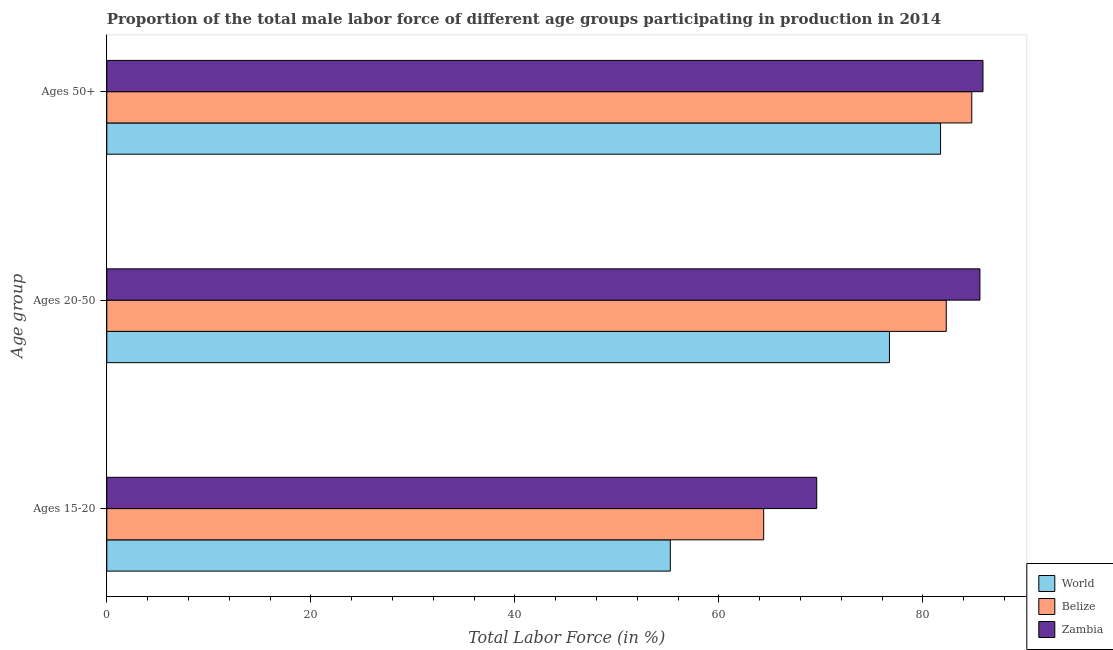How many groups of bars are there?
Keep it short and to the point. 3. Are the number of bars on each tick of the Y-axis equal?
Provide a succinct answer. Yes. How many bars are there on the 3rd tick from the top?
Your response must be concise. 3. How many bars are there on the 3rd tick from the bottom?
Your answer should be compact. 3. What is the label of the 1st group of bars from the top?
Ensure brevity in your answer.  Ages 50+. What is the percentage of male labor force within the age group 20-50 in Zambia?
Ensure brevity in your answer.  85.6. Across all countries, what is the maximum percentage of male labor force above age 50?
Provide a short and direct response. 85.9. Across all countries, what is the minimum percentage of male labor force within the age group 15-20?
Offer a terse response. 55.24. In which country was the percentage of male labor force within the age group 20-50 maximum?
Your answer should be very brief. Zambia. In which country was the percentage of male labor force within the age group 20-50 minimum?
Provide a succinct answer. World. What is the total percentage of male labor force above age 50 in the graph?
Offer a very short reply. 252.44. What is the difference between the percentage of male labor force within the age group 20-50 in Belize and that in Zambia?
Provide a short and direct response. -3.3. What is the difference between the percentage of male labor force above age 50 in World and the percentage of male labor force within the age group 15-20 in Zambia?
Your response must be concise. 12.14. What is the average percentage of male labor force within the age group 20-50 per country?
Your answer should be compact. 81.54. What is the difference between the percentage of male labor force above age 50 and percentage of male labor force within the age group 20-50 in Zambia?
Your response must be concise. 0.3. What is the ratio of the percentage of male labor force within the age group 15-20 in Belize to that in Zambia?
Ensure brevity in your answer.  0.93. Is the percentage of male labor force above age 50 in World less than that in Zambia?
Keep it short and to the point. Yes. Is the difference between the percentage of male labor force within the age group 20-50 in Zambia and Belize greater than the difference between the percentage of male labor force above age 50 in Zambia and Belize?
Keep it short and to the point. Yes. What is the difference between the highest and the second highest percentage of male labor force above age 50?
Ensure brevity in your answer.  1.1. What is the difference between the highest and the lowest percentage of male labor force within the age group 20-50?
Offer a very short reply. 8.87. In how many countries, is the percentage of male labor force above age 50 greater than the average percentage of male labor force above age 50 taken over all countries?
Provide a succinct answer. 2. Is the sum of the percentage of male labor force above age 50 in Zambia and World greater than the maximum percentage of male labor force within the age group 20-50 across all countries?
Make the answer very short. Yes. What does the 2nd bar from the top in Ages 50+ represents?
Provide a short and direct response. Belize. What does the 3rd bar from the bottom in Ages 50+ represents?
Your answer should be very brief. Zambia. Are all the bars in the graph horizontal?
Give a very brief answer. Yes. What is the difference between two consecutive major ticks on the X-axis?
Offer a very short reply. 20. Are the values on the major ticks of X-axis written in scientific E-notation?
Keep it short and to the point. No. How many legend labels are there?
Your answer should be compact. 3. What is the title of the graph?
Keep it short and to the point. Proportion of the total male labor force of different age groups participating in production in 2014. What is the label or title of the X-axis?
Keep it short and to the point. Total Labor Force (in %). What is the label or title of the Y-axis?
Offer a terse response. Age group. What is the Total Labor Force (in %) of World in Ages 15-20?
Your answer should be very brief. 55.24. What is the Total Labor Force (in %) in Belize in Ages 15-20?
Provide a short and direct response. 64.4. What is the Total Labor Force (in %) in Zambia in Ages 15-20?
Provide a short and direct response. 69.6. What is the Total Labor Force (in %) in World in Ages 20-50?
Your response must be concise. 76.73. What is the Total Labor Force (in %) of Belize in Ages 20-50?
Give a very brief answer. 82.3. What is the Total Labor Force (in %) in Zambia in Ages 20-50?
Give a very brief answer. 85.6. What is the Total Labor Force (in %) in World in Ages 50+?
Provide a succinct answer. 81.74. What is the Total Labor Force (in %) in Belize in Ages 50+?
Keep it short and to the point. 84.8. What is the Total Labor Force (in %) in Zambia in Ages 50+?
Make the answer very short. 85.9. Across all Age group, what is the maximum Total Labor Force (in %) of World?
Provide a succinct answer. 81.74. Across all Age group, what is the maximum Total Labor Force (in %) in Belize?
Your answer should be compact. 84.8. Across all Age group, what is the maximum Total Labor Force (in %) of Zambia?
Provide a short and direct response. 85.9. Across all Age group, what is the minimum Total Labor Force (in %) in World?
Your answer should be very brief. 55.24. Across all Age group, what is the minimum Total Labor Force (in %) in Belize?
Offer a very short reply. 64.4. Across all Age group, what is the minimum Total Labor Force (in %) of Zambia?
Keep it short and to the point. 69.6. What is the total Total Labor Force (in %) of World in the graph?
Provide a short and direct response. 213.72. What is the total Total Labor Force (in %) of Belize in the graph?
Your answer should be compact. 231.5. What is the total Total Labor Force (in %) in Zambia in the graph?
Ensure brevity in your answer.  241.1. What is the difference between the Total Labor Force (in %) of World in Ages 15-20 and that in Ages 20-50?
Provide a short and direct response. -21.49. What is the difference between the Total Labor Force (in %) of Belize in Ages 15-20 and that in Ages 20-50?
Your answer should be very brief. -17.9. What is the difference between the Total Labor Force (in %) in Zambia in Ages 15-20 and that in Ages 20-50?
Make the answer very short. -16. What is the difference between the Total Labor Force (in %) in World in Ages 15-20 and that in Ages 50+?
Ensure brevity in your answer.  -26.5. What is the difference between the Total Labor Force (in %) in Belize in Ages 15-20 and that in Ages 50+?
Make the answer very short. -20.4. What is the difference between the Total Labor Force (in %) of Zambia in Ages 15-20 and that in Ages 50+?
Keep it short and to the point. -16.3. What is the difference between the Total Labor Force (in %) in World in Ages 20-50 and that in Ages 50+?
Your answer should be compact. -5.01. What is the difference between the Total Labor Force (in %) in World in Ages 15-20 and the Total Labor Force (in %) in Belize in Ages 20-50?
Offer a terse response. -27.06. What is the difference between the Total Labor Force (in %) in World in Ages 15-20 and the Total Labor Force (in %) in Zambia in Ages 20-50?
Provide a short and direct response. -30.36. What is the difference between the Total Labor Force (in %) in Belize in Ages 15-20 and the Total Labor Force (in %) in Zambia in Ages 20-50?
Your answer should be compact. -21.2. What is the difference between the Total Labor Force (in %) in World in Ages 15-20 and the Total Labor Force (in %) in Belize in Ages 50+?
Give a very brief answer. -29.56. What is the difference between the Total Labor Force (in %) of World in Ages 15-20 and the Total Labor Force (in %) of Zambia in Ages 50+?
Your answer should be very brief. -30.66. What is the difference between the Total Labor Force (in %) in Belize in Ages 15-20 and the Total Labor Force (in %) in Zambia in Ages 50+?
Your answer should be compact. -21.5. What is the difference between the Total Labor Force (in %) of World in Ages 20-50 and the Total Labor Force (in %) of Belize in Ages 50+?
Your answer should be very brief. -8.07. What is the difference between the Total Labor Force (in %) of World in Ages 20-50 and the Total Labor Force (in %) of Zambia in Ages 50+?
Keep it short and to the point. -9.17. What is the average Total Labor Force (in %) in World per Age group?
Keep it short and to the point. 71.24. What is the average Total Labor Force (in %) in Belize per Age group?
Make the answer very short. 77.17. What is the average Total Labor Force (in %) in Zambia per Age group?
Your answer should be very brief. 80.37. What is the difference between the Total Labor Force (in %) of World and Total Labor Force (in %) of Belize in Ages 15-20?
Offer a terse response. -9.16. What is the difference between the Total Labor Force (in %) of World and Total Labor Force (in %) of Zambia in Ages 15-20?
Give a very brief answer. -14.36. What is the difference between the Total Labor Force (in %) of World and Total Labor Force (in %) of Belize in Ages 20-50?
Provide a succinct answer. -5.57. What is the difference between the Total Labor Force (in %) of World and Total Labor Force (in %) of Zambia in Ages 20-50?
Give a very brief answer. -8.87. What is the difference between the Total Labor Force (in %) of Belize and Total Labor Force (in %) of Zambia in Ages 20-50?
Your answer should be compact. -3.3. What is the difference between the Total Labor Force (in %) of World and Total Labor Force (in %) of Belize in Ages 50+?
Keep it short and to the point. -3.06. What is the difference between the Total Labor Force (in %) of World and Total Labor Force (in %) of Zambia in Ages 50+?
Make the answer very short. -4.16. What is the ratio of the Total Labor Force (in %) of World in Ages 15-20 to that in Ages 20-50?
Offer a very short reply. 0.72. What is the ratio of the Total Labor Force (in %) in Belize in Ages 15-20 to that in Ages 20-50?
Give a very brief answer. 0.78. What is the ratio of the Total Labor Force (in %) of Zambia in Ages 15-20 to that in Ages 20-50?
Your answer should be compact. 0.81. What is the ratio of the Total Labor Force (in %) of World in Ages 15-20 to that in Ages 50+?
Your answer should be very brief. 0.68. What is the ratio of the Total Labor Force (in %) in Belize in Ages 15-20 to that in Ages 50+?
Offer a terse response. 0.76. What is the ratio of the Total Labor Force (in %) in Zambia in Ages 15-20 to that in Ages 50+?
Give a very brief answer. 0.81. What is the ratio of the Total Labor Force (in %) of World in Ages 20-50 to that in Ages 50+?
Provide a succinct answer. 0.94. What is the ratio of the Total Labor Force (in %) of Belize in Ages 20-50 to that in Ages 50+?
Your response must be concise. 0.97. What is the difference between the highest and the second highest Total Labor Force (in %) of World?
Offer a terse response. 5.01. What is the difference between the highest and the second highest Total Labor Force (in %) of Belize?
Offer a terse response. 2.5. What is the difference between the highest and the second highest Total Labor Force (in %) of Zambia?
Keep it short and to the point. 0.3. What is the difference between the highest and the lowest Total Labor Force (in %) of World?
Give a very brief answer. 26.5. What is the difference between the highest and the lowest Total Labor Force (in %) of Belize?
Your answer should be compact. 20.4. What is the difference between the highest and the lowest Total Labor Force (in %) of Zambia?
Make the answer very short. 16.3. 